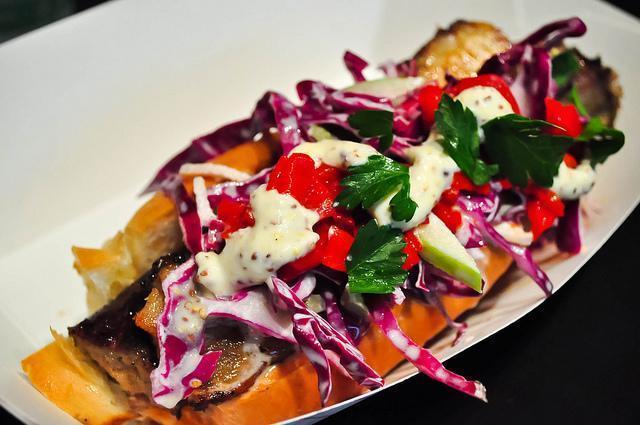How many beds are in this room?
Give a very brief answer. 0. 